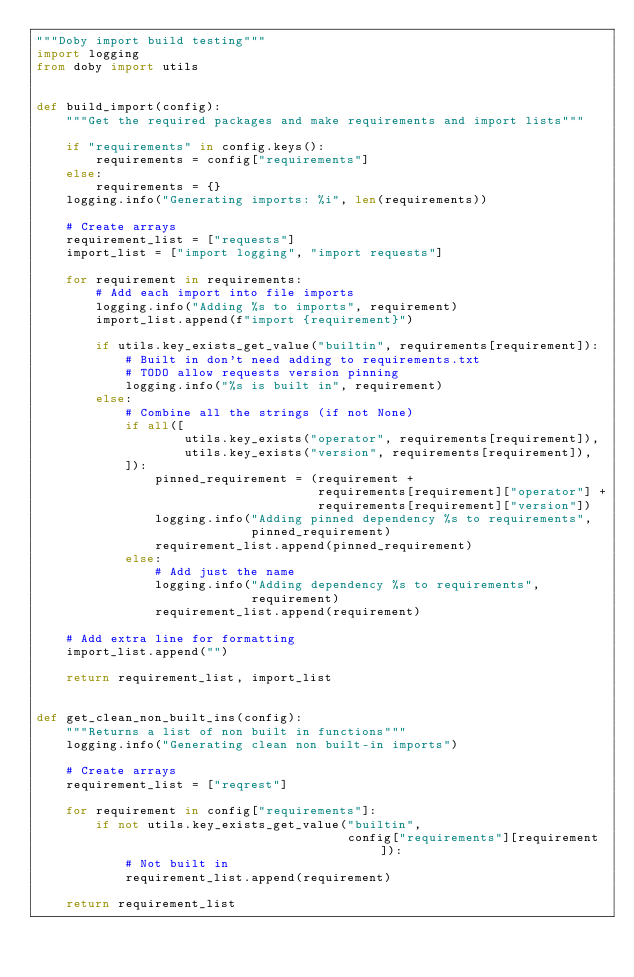<code> <loc_0><loc_0><loc_500><loc_500><_Python_>"""Doby import build testing"""
import logging
from doby import utils


def build_import(config):
    """Get the required packages and make requirements and import lists"""

    if "requirements" in config.keys():
        requirements = config["requirements"]
    else:
        requirements = {}
    logging.info("Generating imports: %i", len(requirements))

    # Create arrays
    requirement_list = ["requests"]
    import_list = ["import logging", "import requests"]

    for requirement in requirements:
        # Add each import into file imports
        logging.info("Adding %s to imports", requirement)
        import_list.append(f"import {requirement}")

        if utils.key_exists_get_value("builtin", requirements[requirement]):
            # Built in don't need adding to requirements.txt
            # TODO allow requests version pinning
            logging.info("%s is built in", requirement)
        else:
            # Combine all the strings (if not None)
            if all([
                    utils.key_exists("operator", requirements[requirement]),
                    utils.key_exists("version", requirements[requirement]),
            ]):
                pinned_requirement = (requirement +
                                      requirements[requirement]["operator"] +
                                      requirements[requirement]["version"])
                logging.info("Adding pinned dependency %s to requirements",
                             pinned_requirement)
                requirement_list.append(pinned_requirement)
            else:
                # Add just the name
                logging.info("Adding dependency %s to requirements",
                             requirement)
                requirement_list.append(requirement)

    # Add extra line for formatting
    import_list.append("")

    return requirement_list, import_list


def get_clean_non_built_ins(config):
    """Returns a list of non built in functions"""
    logging.info("Generating clean non built-in imports")

    # Create arrays
    requirement_list = ["reqrest"]

    for requirement in config["requirements"]:
        if not utils.key_exists_get_value("builtin",
                                          config["requirements"][requirement]):
            # Not built in
            requirement_list.append(requirement)

    return requirement_list
</code> 